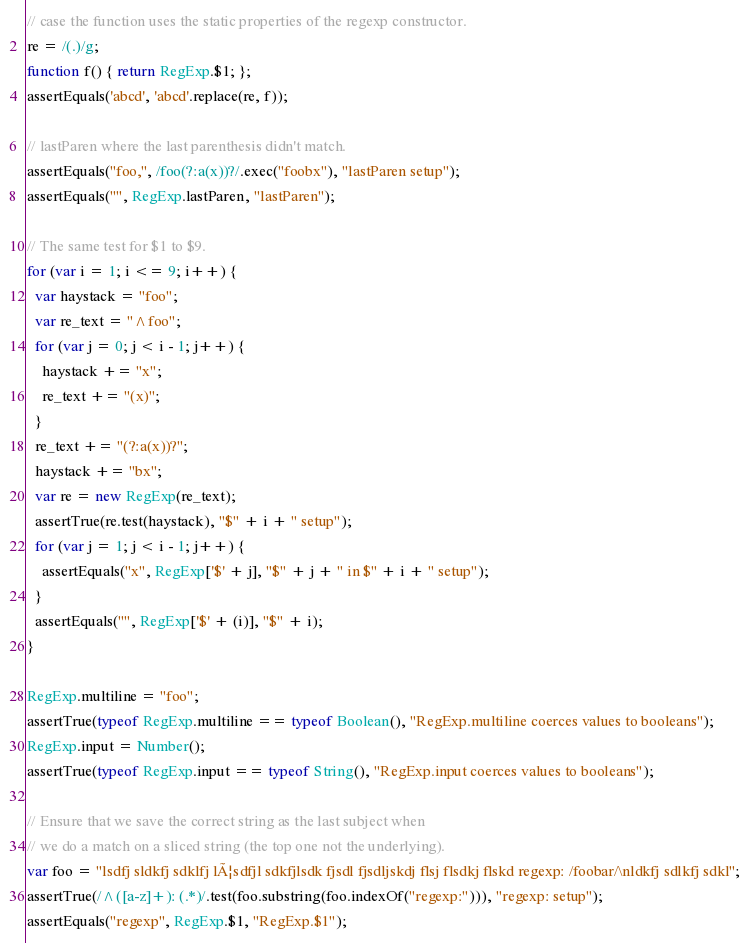Convert code to text. <code><loc_0><loc_0><loc_500><loc_500><_JavaScript_>// case the function uses the static properties of the regexp constructor.
re = /(.)/g;
function f() { return RegExp.$1; };
assertEquals('abcd', 'abcd'.replace(re, f));

// lastParen where the last parenthesis didn't match.
assertEquals("foo,", /foo(?:a(x))?/.exec("foobx"), "lastParen setup");
assertEquals("", RegExp.lastParen, "lastParen");

// The same test for $1 to $9.
for (var i = 1; i <= 9; i++) {
  var haystack = "foo";
  var re_text = "^foo";
  for (var j = 0; j < i - 1; j++) {
    haystack += "x";
    re_text += "(x)";
  }
  re_text += "(?:a(x))?";
  haystack += "bx";
  var re = new RegExp(re_text);
  assertTrue(re.test(haystack), "$" + i + " setup");
  for (var j = 1; j < i - 1; j++) {
    assertEquals("x", RegExp['$' + j], "$" + j + " in $" + i + " setup");
  }
  assertEquals("", RegExp['$' + (i)], "$" + i);
}

RegExp.multiline = "foo";
assertTrue(typeof RegExp.multiline == typeof Boolean(), "RegExp.multiline coerces values to booleans");
RegExp.input = Number();
assertTrue(typeof RegExp.input == typeof String(), "RegExp.input coerces values to booleans");

// Ensure that we save the correct string as the last subject when
// we do a match on a sliced string (the top one not the underlying).
var foo = "lsdfj sldkfj sdklfj lÃ¦sdfjl sdkfjlsdk fjsdl fjsdljskdj flsj flsdkj flskd regexp: /foobar/\nldkfj sdlkfj sdkl";
assertTrue(/^([a-z]+): (.*)/.test(foo.substring(foo.indexOf("regexp:"))), "regexp: setup");
assertEquals("regexp", RegExp.$1, "RegExp.$1");
</code> 